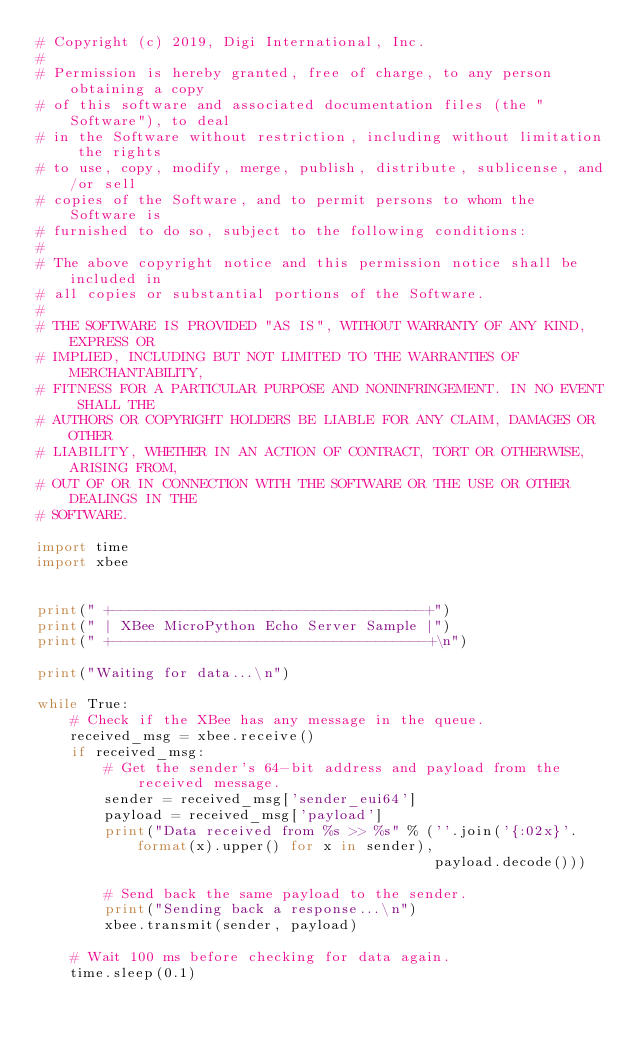<code> <loc_0><loc_0><loc_500><loc_500><_Python_># Copyright (c) 2019, Digi International, Inc.
#
# Permission is hereby granted, free of charge, to any person obtaining a copy
# of this software and associated documentation files (the "Software"), to deal
# in the Software without restriction, including without limitation the rights
# to use, copy, modify, merge, publish, distribute, sublicense, and/or sell
# copies of the Software, and to permit persons to whom the Software is
# furnished to do so, subject to the following conditions:
#
# The above copyright notice and this permission notice shall be included in
# all copies or substantial portions of the Software.
#
# THE SOFTWARE IS PROVIDED "AS IS", WITHOUT WARRANTY OF ANY KIND, EXPRESS OR
# IMPLIED, INCLUDING BUT NOT LIMITED TO THE WARRANTIES OF MERCHANTABILITY,
# FITNESS FOR A PARTICULAR PURPOSE AND NONINFRINGEMENT. IN NO EVENT SHALL THE
# AUTHORS OR COPYRIGHT HOLDERS BE LIABLE FOR ANY CLAIM, DAMAGES OR OTHER
# LIABILITY, WHETHER IN AN ACTION OF CONTRACT, TORT OR OTHERWISE, ARISING FROM,
# OUT OF OR IN CONNECTION WITH THE SOFTWARE OR THE USE OR OTHER DEALINGS IN THE
# SOFTWARE.

import time
import xbee


print(" +-------------------------------------+")
print(" | XBee MicroPython Echo Server Sample |")
print(" +-------------------------------------+\n")

print("Waiting for data...\n")

while True:
    # Check if the XBee has any message in the queue.
    received_msg = xbee.receive()
    if received_msg:
        # Get the sender's 64-bit address and payload from the received message.
        sender = received_msg['sender_eui64']
        payload = received_msg['payload']
        print("Data received from %s >> %s" % (''.join('{:02x}'.format(x).upper() for x in sender),
                                               payload.decode()))

        # Send back the same payload to the sender.
        print("Sending back a response...\n")
        xbee.transmit(sender, payload)

    # Wait 100 ms before checking for data again.
    time.sleep(0.1)
</code> 